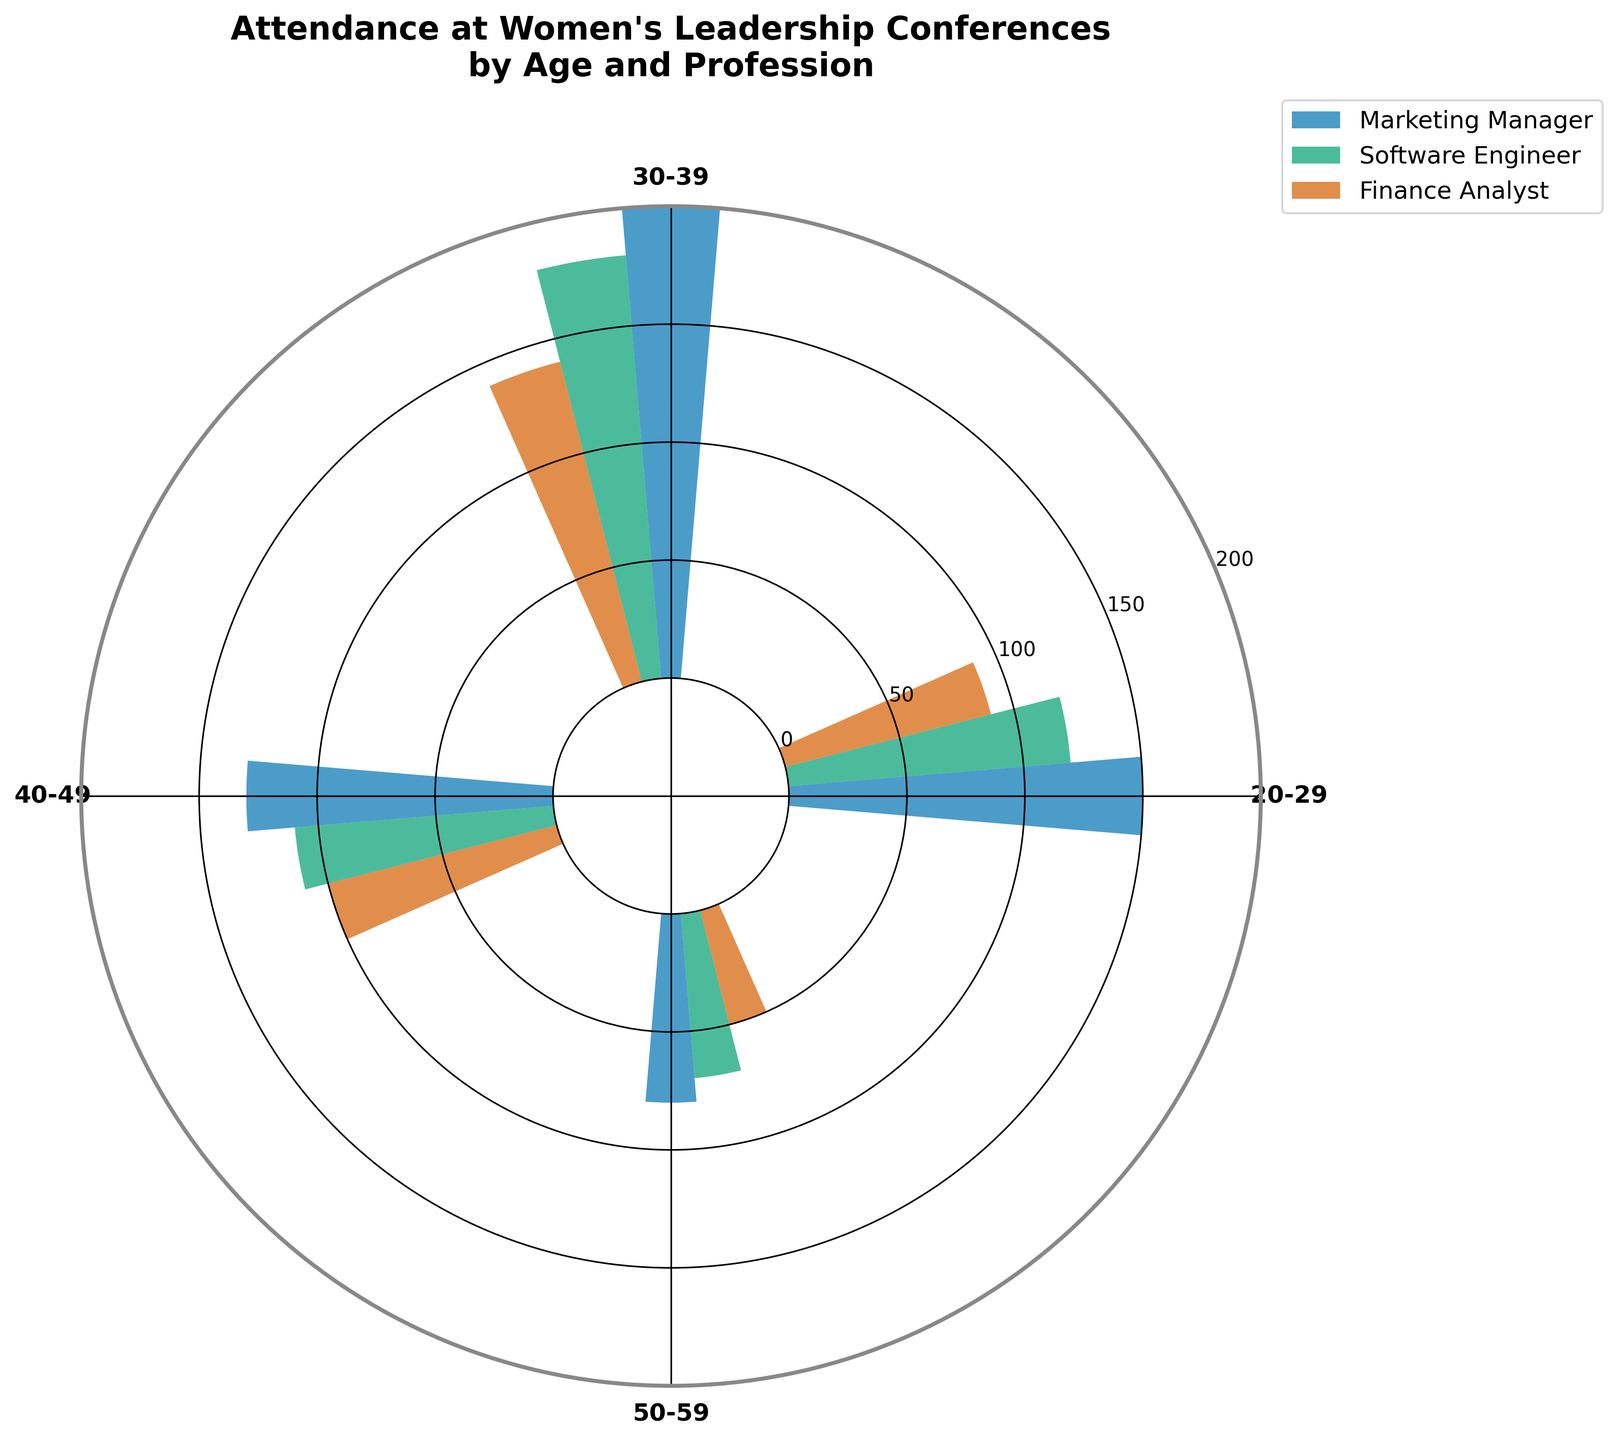What's the title of the chart? The title is located at the top center of the chart and provides a summary of the data being presented. It reads, "Attendance at Women's Leadership Conferences by Age and Profession".
Answer: Attendance at Women's Leadership Conferences by Age and Profession Which profession had the highest attendance in the 30-39 age group? Looking at the θ tick labels for the 30-39 age group and comparing the heights (or lengths) of the bars for each profession, the Marketing Manager's bar is the highest among them.
Answer: Marketing Manager How does the attendance of Finance Analysts in the 50-59 age group compare to the 20-29 age group? To answer this, find the positions for the 50-59 and 20-29 Finance Analyst bars and compare their heights. The 50-59 age group has an attendance of 50, while the 20-29 age group has 90. Thus, the attendance in the 50-59 age group is less than half of that in the 20-29 group.
Answer: Less than half What is the total attendance for Software Engineers across all age groups? Sum the attendance counts for Software Engineers across all age groups: 120 (20-29) + 180 (30-39) + 110 (40-49) + 70 (50-59). The total is 480.
Answer: 480 What is the average attendance of Marketing Managers across the different age groups? First, sum the attendance counts for Marketing Managers: 150 (20-29) + 200 (30-39) + 130 (40-49) + 80 (50-59). Then, divide the total by the number of age groups: (150 + 200 + 130 + 80) / 4 = 140.
Answer: 140 Between the 30-39 and 40-49 age groups, which one has a higher total attendance across all professions? Sum the attendance for each profession in the 30-39 and 40-49 age groups. For 30-39: 200 (Marketing) + 180 (Software) + 140 (Finance) = 520. For 40-49: 130 (Marketing) + 110 (Software) + 100 (Finance) = 340. The 30-39 age group has a higher total attendance.
Answer: 30-39 Which age group shows the least variance in attendance across professions? Compare the range of attendance counts for each age group: 
* 20-29: 150 - 90 = 60
* 30-39: 200 - 140 = 60
* 40-49: 130 - 100 = 30
* 50-59: 80 - 50 = 30
The age group 40-49 and 50-59 both show the same, smallest variance of 30.
Answer: 40-49 and 50-59 